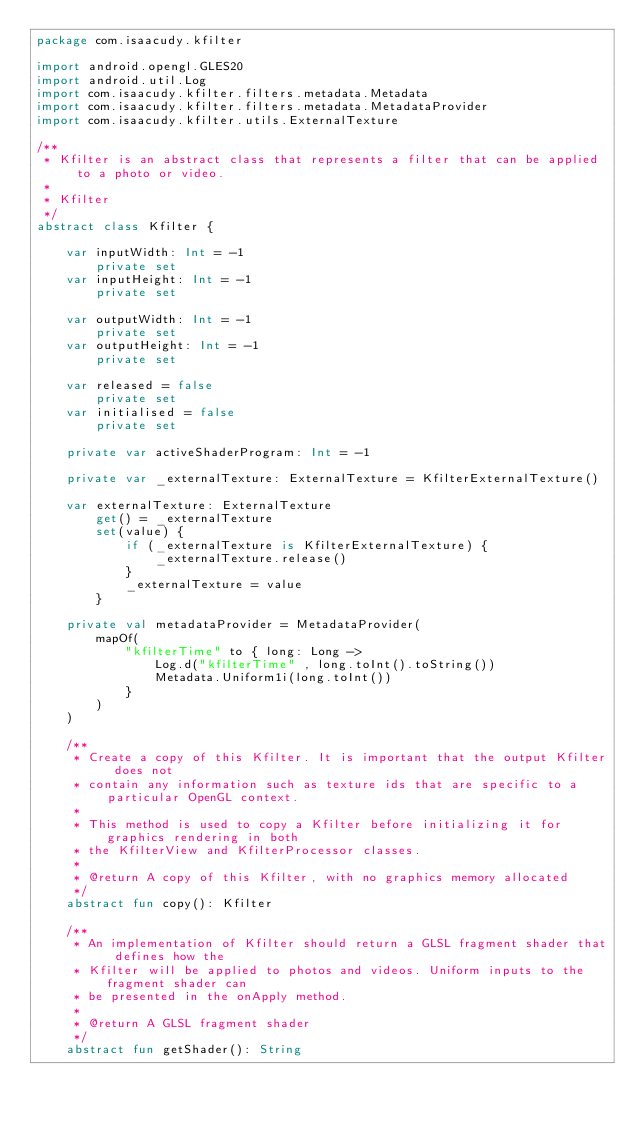Convert code to text. <code><loc_0><loc_0><loc_500><loc_500><_Kotlin_>package com.isaacudy.kfilter

import android.opengl.GLES20
import android.util.Log
import com.isaacudy.kfilter.filters.metadata.Metadata
import com.isaacudy.kfilter.filters.metadata.MetadataProvider
import com.isaacudy.kfilter.utils.ExternalTexture

/**
 * Kfilter is an abstract class that represents a filter that can be applied to a photo or video.
 *
 * Kfilter
 */
abstract class Kfilter {

    var inputWidth: Int = -1
        private set
    var inputHeight: Int = -1
        private set

    var outputWidth: Int = -1
        private set
    var outputHeight: Int = -1
        private set

    var released = false
        private set
    var initialised = false
        private set

    private var activeShaderProgram: Int = -1

    private var _externalTexture: ExternalTexture = KfilterExternalTexture()

    var externalTexture: ExternalTexture
        get() = _externalTexture
        set(value) {
            if (_externalTexture is KfilterExternalTexture) {
                _externalTexture.release()
            }
            _externalTexture = value
        }

    private val metadataProvider = MetadataProvider(
        mapOf(
            "kfilterTime" to { long: Long ->
                Log.d("kfilterTime" , long.toInt().toString())
                Metadata.Uniform1i(long.toInt())
            }
        )
    )

    /**
     * Create a copy of this Kfilter. It is important that the output Kfilter does not
     * contain any information such as texture ids that are specific to a particular OpenGL context.
     *
     * This method is used to copy a Kfilter before initializing it for graphics rendering in both
     * the KfilterView and KfilterProcessor classes.
     *
     * @return A copy of this Kfilter, with no graphics memory allocated
     */
    abstract fun copy(): Kfilter

    /**
     * An implementation of Kfilter should return a GLSL fragment shader that defines how the
     * Kfilter will be applied to photos and videos. Uniform inputs to the fragment shader can
     * be presented in the onApply method.
     *
     * @return A GLSL fragment shader
     */
    abstract fun getShader(): String
</code> 